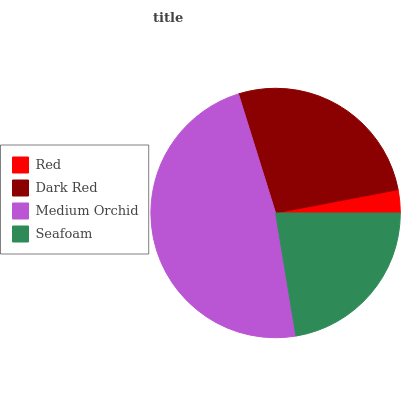Is Red the minimum?
Answer yes or no. Yes. Is Medium Orchid the maximum?
Answer yes or no. Yes. Is Dark Red the minimum?
Answer yes or no. No. Is Dark Red the maximum?
Answer yes or no. No. Is Dark Red greater than Red?
Answer yes or no. Yes. Is Red less than Dark Red?
Answer yes or no. Yes. Is Red greater than Dark Red?
Answer yes or no. No. Is Dark Red less than Red?
Answer yes or no. No. Is Dark Red the high median?
Answer yes or no. Yes. Is Seafoam the low median?
Answer yes or no. Yes. Is Medium Orchid the high median?
Answer yes or no. No. Is Red the low median?
Answer yes or no. No. 